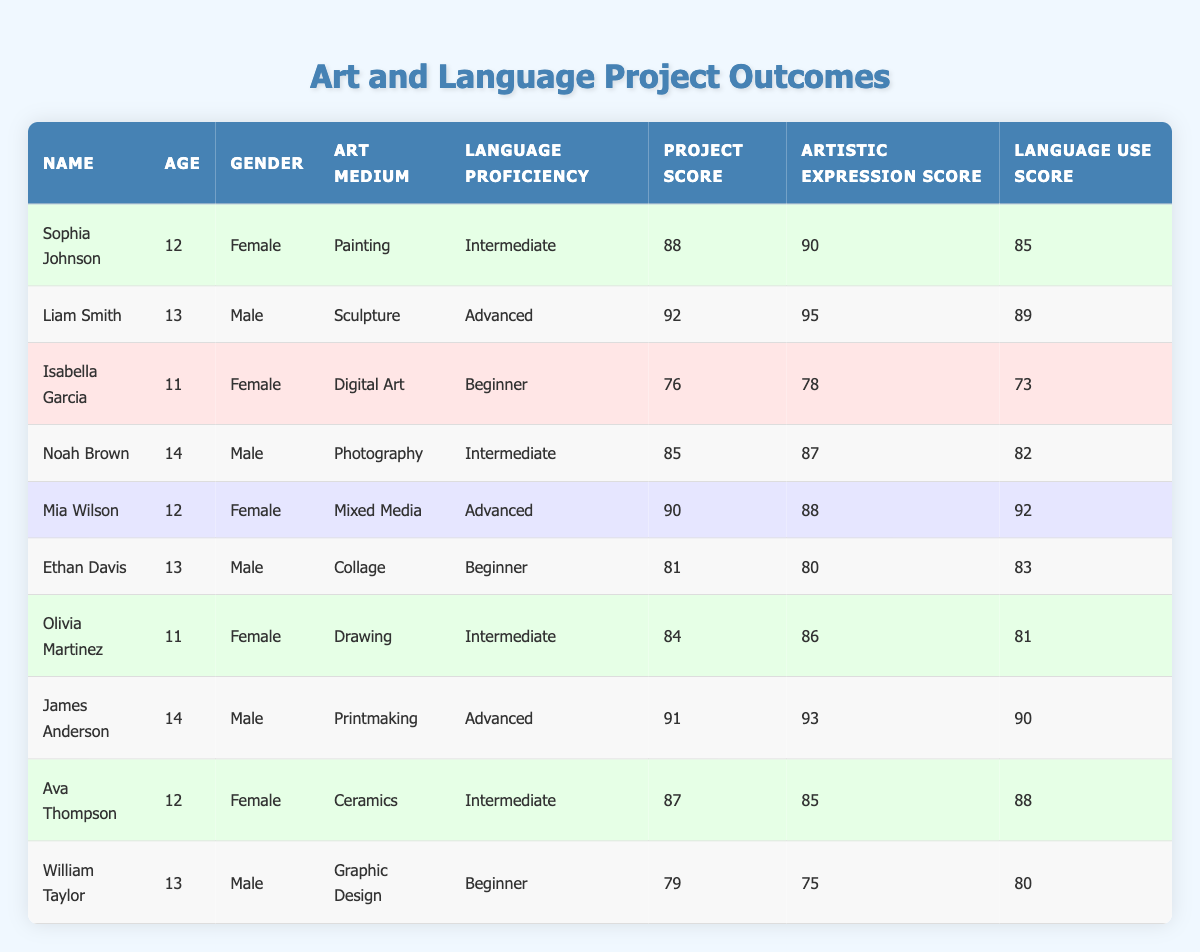What is the highest Project Score in the table? By reviewing the Project Score column, the scores range from 76 to 92. The highest score is 92.
Answer: 92 Which student has the lowest Artistic Expression Score? The Artistic Expression Scores for each student are 90, 95, 78, 87, 88, 80, 86, 93, 85, and 75. The lowest score is 75, which belongs to William Taylor.
Answer: 75 How many students have a Language Proficiency level of Intermediate? The students with Intermediate proficiency are Sophia Johnson, Noah Brown, Olivia Martinez, and Ava Thompson, totaling 4 students.
Answer: 4 What is the average Project Score for all students? The Project Scores are 88, 92, 76, 85, 90, 81, 84, 91, 87, and 79. Their sum is  88 + 92 + 76 + 85 + 90 + 81 + 84 + 91 + 87 + 79 =  92 = 922. Dividing by 10 gives an average of 922 / 10 = 92.2.
Answer: 92.2 Is Mia Wilson's Language Use Score higher than 90? Mia Wilson's Language Use Score is 92, which is higher than 90. Therefore, the statement is true.
Answer: Yes Which art medium is associated with the student who has the lowest Language Use Score? The student with the lowest Language Use Score is Isabella Garcia, whose art medium is Digital Art.
Answer: Digital Art What is the difference between the highest and lowest Project Scores? The highest Project Score is 92 (Liam Smith) and the lowest is 76 (Isabella Garcia). The difference is 92 - 76 = 16.
Answer: 16 How many male students scored above 85 on their Project Score? The students who scored above 85 are Liam Smith (92), Noah Brown (85), James Anderson (91), totaling 3 male students.
Answer: 3 Which student had the highest Artistic Expression Score and what was that score? James Anderson had the highest Artistic Expression Score of 93.
Answer: James Anderson, 93 Count the number of students who used Sculpture as their art medium. Only Liam Smith used Sculpture as his art medium, providing a count of 1.
Answer: 1 